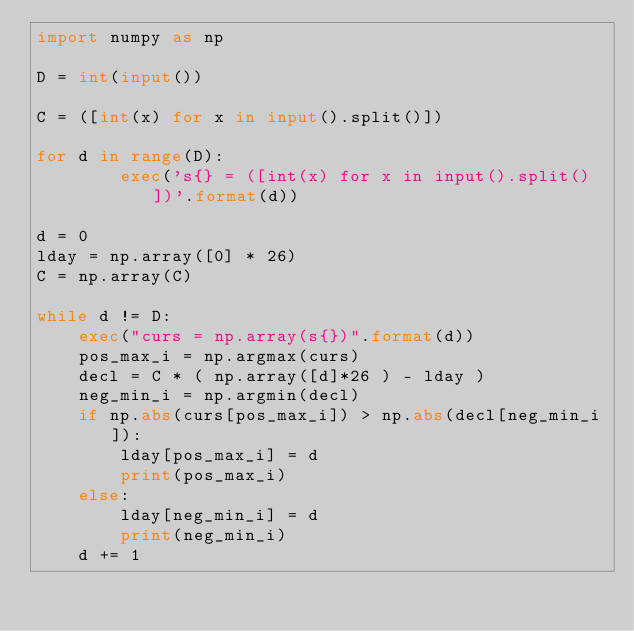Convert code to text. <code><loc_0><loc_0><loc_500><loc_500><_Python_>import numpy as np

D = int(input())

C = ([int(x) for x in input().split()])

for d in range(D):
        exec('s{} = ([int(x) for x in input().split()])'.format(d))

d = 0
lday = np.array([0] * 26)
C = np.array(C)

while d != D:
    exec("curs = np.array(s{})".format(d))
    pos_max_i = np.argmax(curs)
    decl = C * ( np.array([d]*26 ) - lday )
    neg_min_i = np.argmin(decl)
    if np.abs(curs[pos_max_i]) > np.abs(decl[neg_min_i]):
        lday[pos_max_i] = d
        print(pos_max_i)
    else:
        lday[neg_min_i] = d
        print(neg_min_i)
    d += 1</code> 